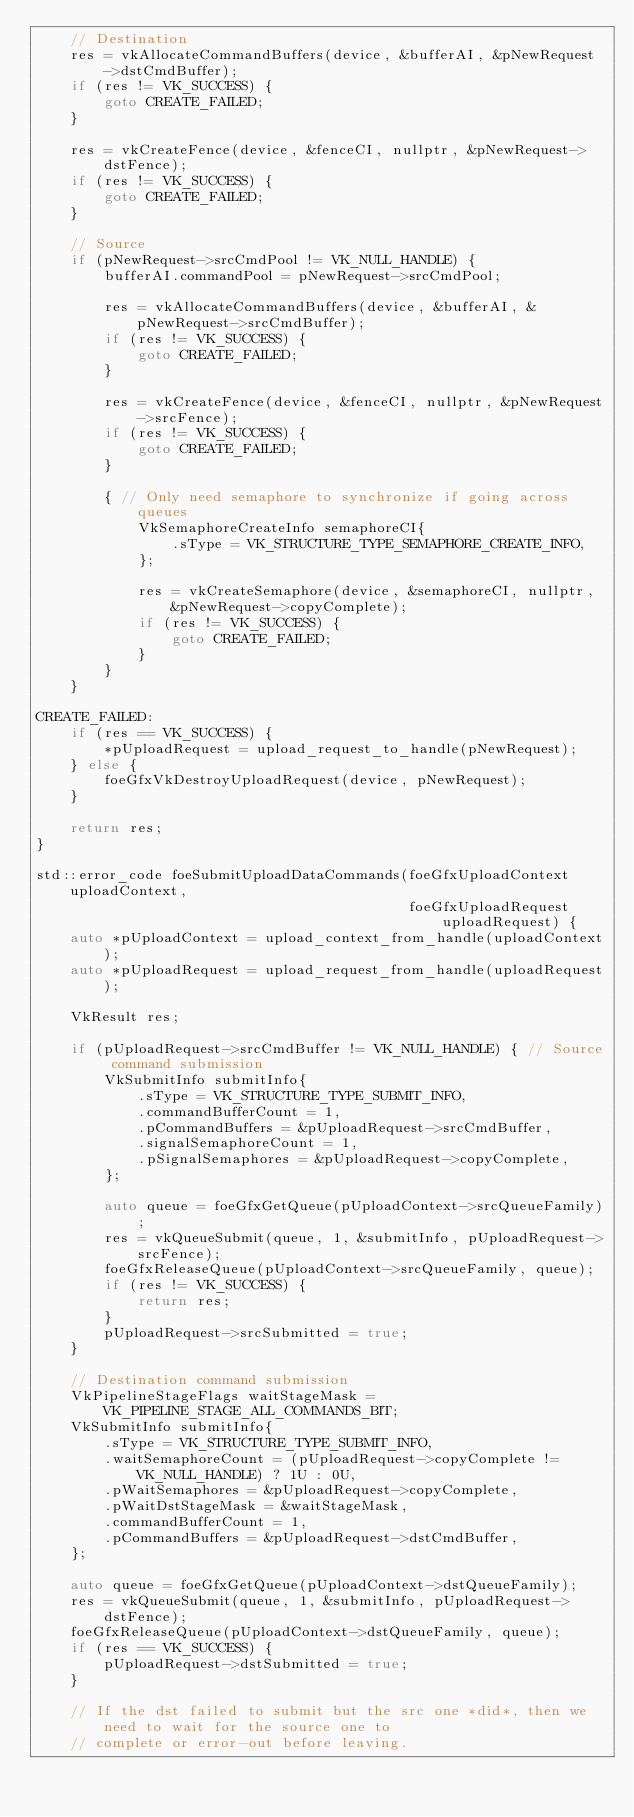Convert code to text. <code><loc_0><loc_0><loc_500><loc_500><_C++_>    // Destination
    res = vkAllocateCommandBuffers(device, &bufferAI, &pNewRequest->dstCmdBuffer);
    if (res != VK_SUCCESS) {
        goto CREATE_FAILED;
    }

    res = vkCreateFence(device, &fenceCI, nullptr, &pNewRequest->dstFence);
    if (res != VK_SUCCESS) {
        goto CREATE_FAILED;
    }

    // Source
    if (pNewRequest->srcCmdPool != VK_NULL_HANDLE) {
        bufferAI.commandPool = pNewRequest->srcCmdPool;

        res = vkAllocateCommandBuffers(device, &bufferAI, &pNewRequest->srcCmdBuffer);
        if (res != VK_SUCCESS) {
            goto CREATE_FAILED;
        }

        res = vkCreateFence(device, &fenceCI, nullptr, &pNewRequest->srcFence);
        if (res != VK_SUCCESS) {
            goto CREATE_FAILED;
        }

        { // Only need semaphore to synchronize if going across queues
            VkSemaphoreCreateInfo semaphoreCI{
                .sType = VK_STRUCTURE_TYPE_SEMAPHORE_CREATE_INFO,
            };

            res = vkCreateSemaphore(device, &semaphoreCI, nullptr, &pNewRequest->copyComplete);
            if (res != VK_SUCCESS) {
                goto CREATE_FAILED;
            }
        }
    }

CREATE_FAILED:
    if (res == VK_SUCCESS) {
        *pUploadRequest = upload_request_to_handle(pNewRequest);
    } else {
        foeGfxVkDestroyUploadRequest(device, pNewRequest);
    }

    return res;
}

std::error_code foeSubmitUploadDataCommands(foeGfxUploadContext uploadContext,
                                            foeGfxUploadRequest uploadRequest) {
    auto *pUploadContext = upload_context_from_handle(uploadContext);
    auto *pUploadRequest = upload_request_from_handle(uploadRequest);

    VkResult res;

    if (pUploadRequest->srcCmdBuffer != VK_NULL_HANDLE) { // Source command submission
        VkSubmitInfo submitInfo{
            .sType = VK_STRUCTURE_TYPE_SUBMIT_INFO,
            .commandBufferCount = 1,
            .pCommandBuffers = &pUploadRequest->srcCmdBuffer,
            .signalSemaphoreCount = 1,
            .pSignalSemaphores = &pUploadRequest->copyComplete,
        };

        auto queue = foeGfxGetQueue(pUploadContext->srcQueueFamily);
        res = vkQueueSubmit(queue, 1, &submitInfo, pUploadRequest->srcFence);
        foeGfxReleaseQueue(pUploadContext->srcQueueFamily, queue);
        if (res != VK_SUCCESS) {
            return res;
        }
        pUploadRequest->srcSubmitted = true;
    }

    // Destination command submission
    VkPipelineStageFlags waitStageMask = VK_PIPELINE_STAGE_ALL_COMMANDS_BIT;
    VkSubmitInfo submitInfo{
        .sType = VK_STRUCTURE_TYPE_SUBMIT_INFO,
        .waitSemaphoreCount = (pUploadRequest->copyComplete != VK_NULL_HANDLE) ? 1U : 0U,
        .pWaitSemaphores = &pUploadRequest->copyComplete,
        .pWaitDstStageMask = &waitStageMask,
        .commandBufferCount = 1,
        .pCommandBuffers = &pUploadRequest->dstCmdBuffer,
    };

    auto queue = foeGfxGetQueue(pUploadContext->dstQueueFamily);
    res = vkQueueSubmit(queue, 1, &submitInfo, pUploadRequest->dstFence);
    foeGfxReleaseQueue(pUploadContext->dstQueueFamily, queue);
    if (res == VK_SUCCESS) {
        pUploadRequest->dstSubmitted = true;
    }

    // If the dst failed to submit but the src one *did*, then we need to wait for the source one to
    // complete or error-out before leaving.</code> 